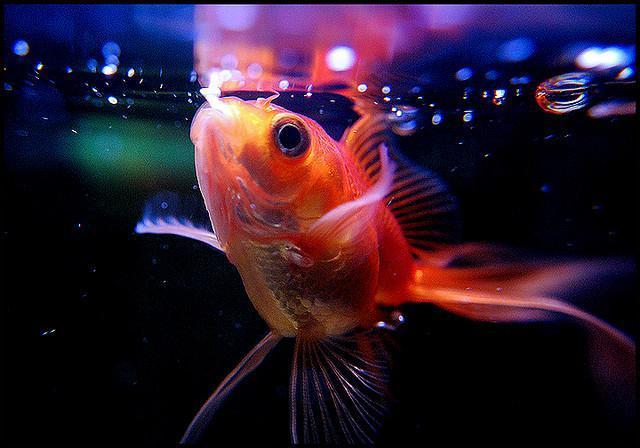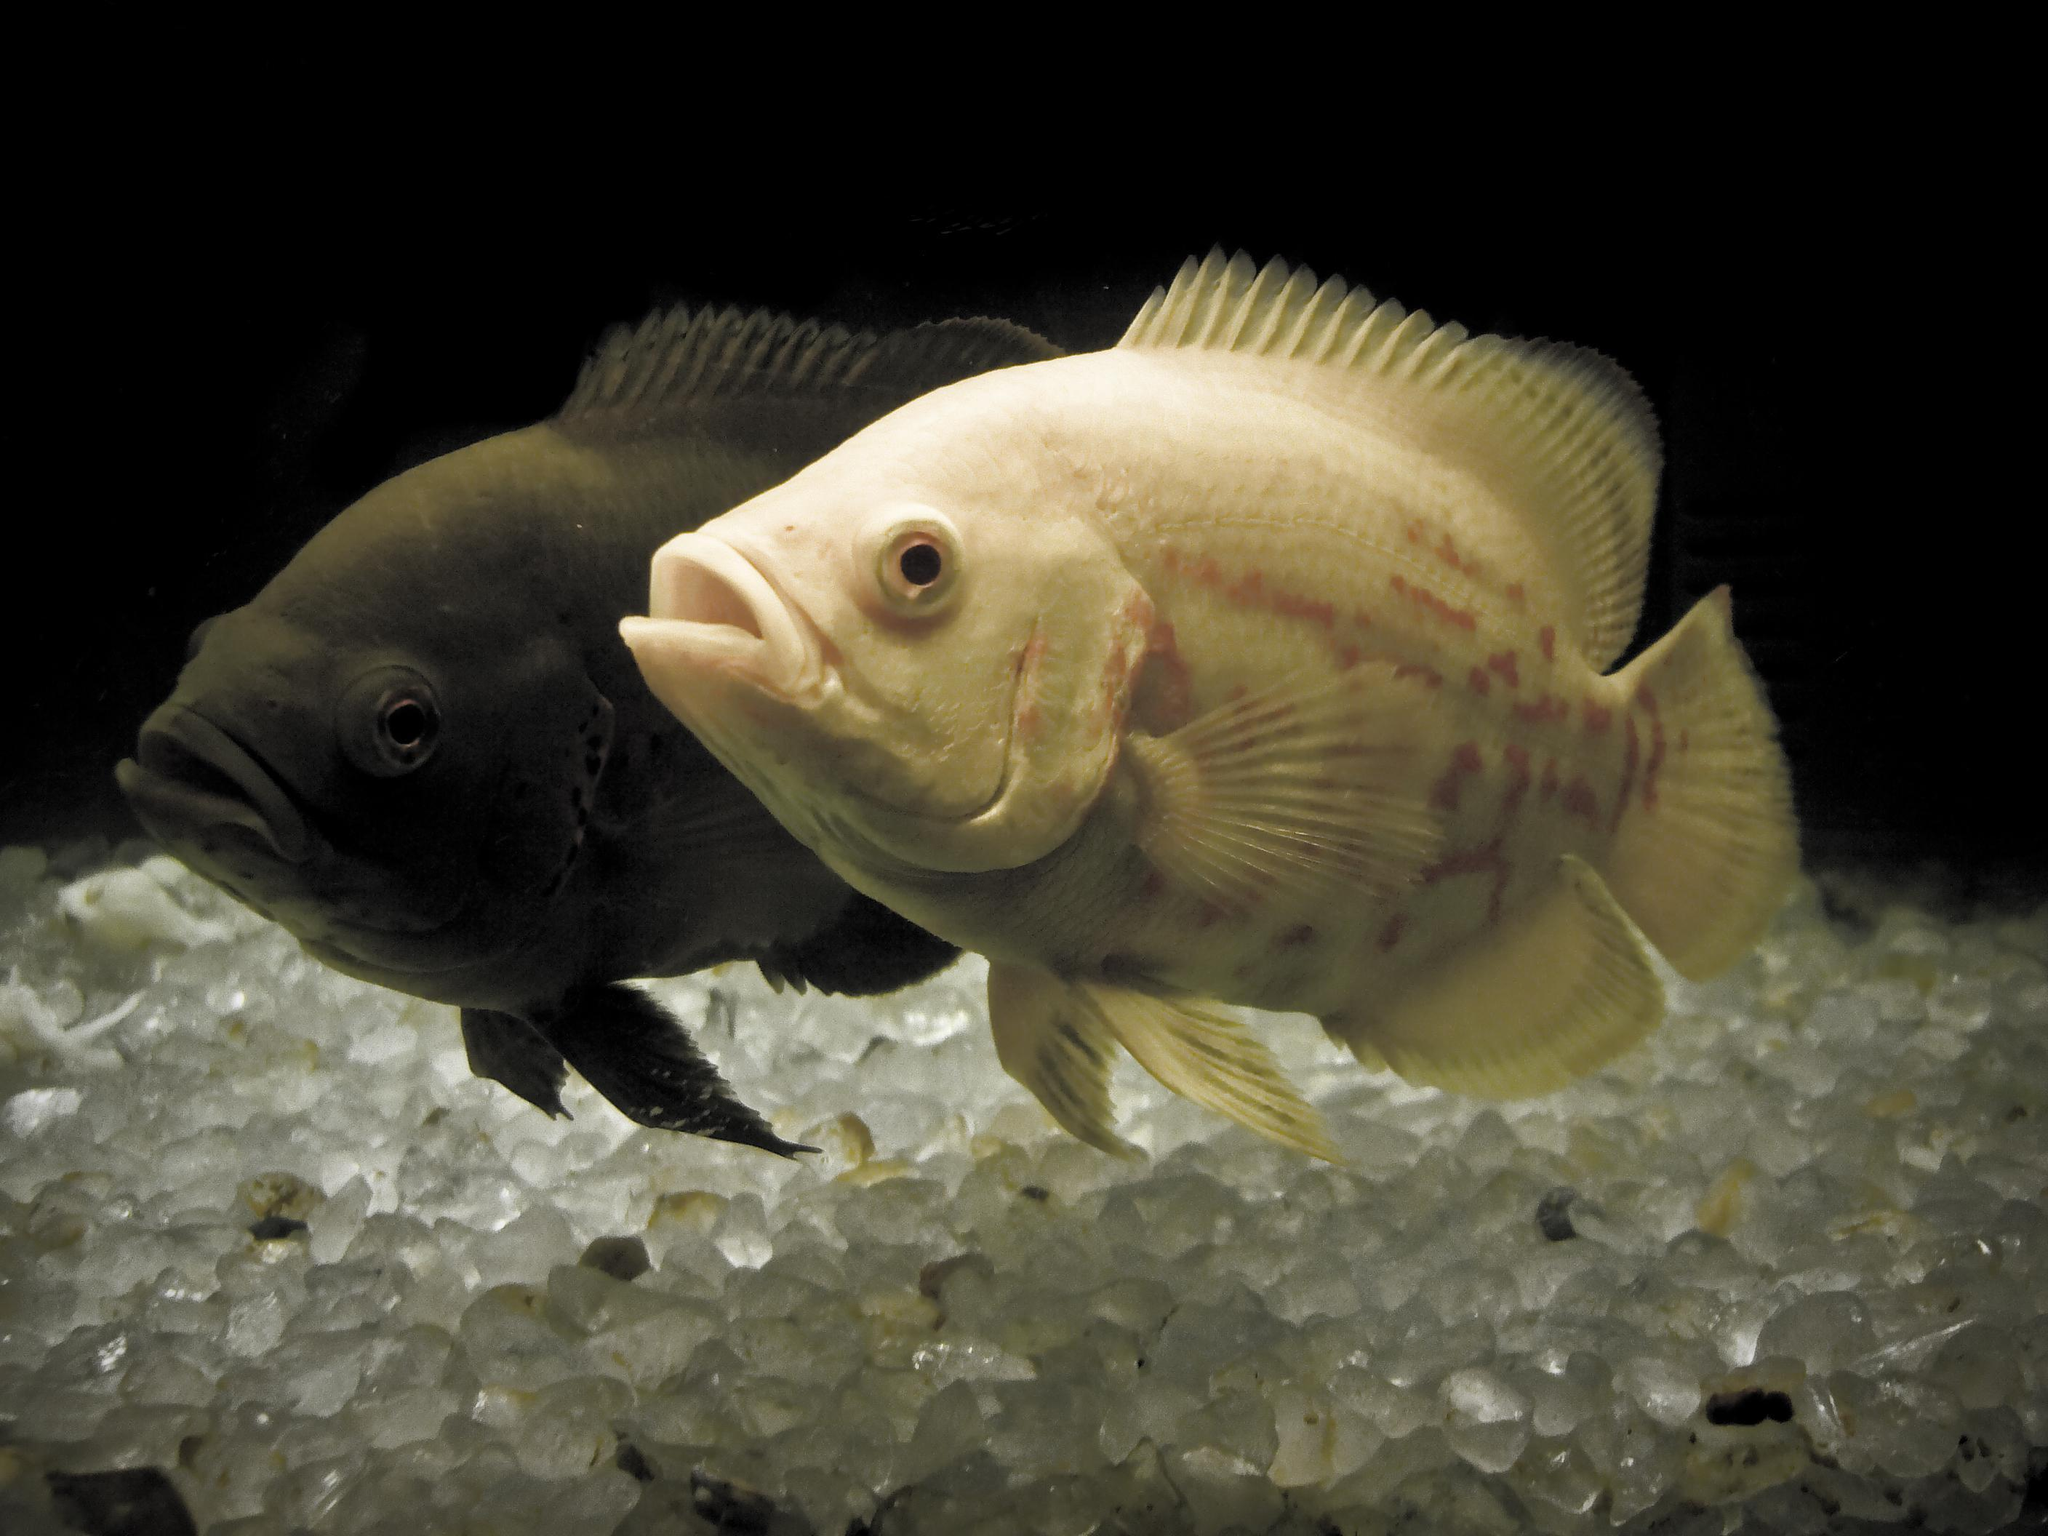The first image is the image on the left, the second image is the image on the right. Given the left and right images, does the statement "The right image shows a single prominent fish displayed in profile with some blue coloring, and the left image shows beds of coral or anemone with no fish present and with touches of violet color." hold true? Answer yes or no. No. The first image is the image on the left, the second image is the image on the right. For the images shown, is this caption "Some fish are facing toward the right." true? Answer yes or no. No. 